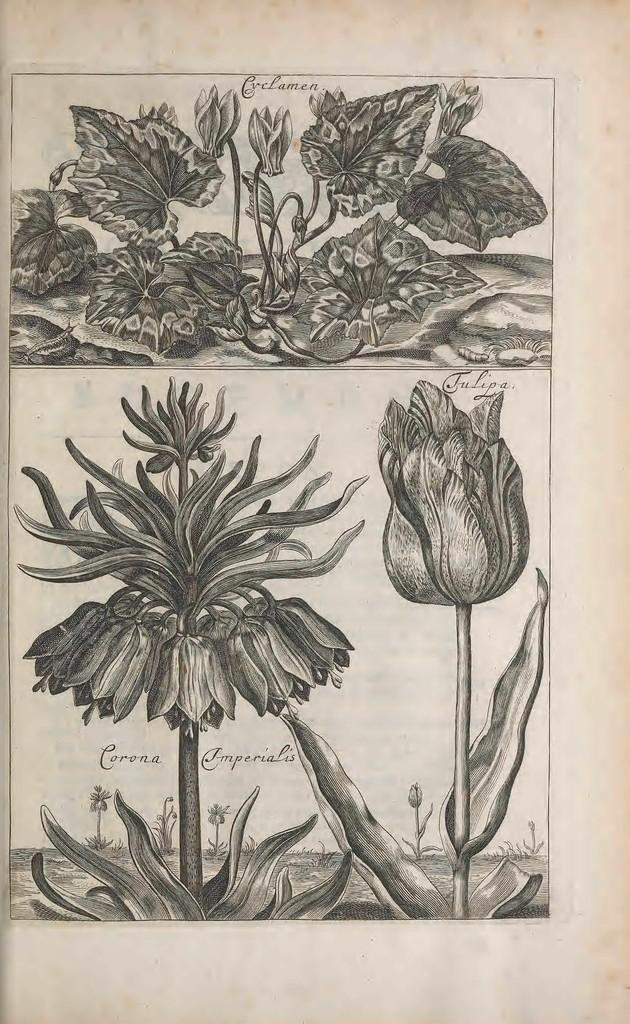What is depicted in the image? The image contains a sketch of flowers. What is the medium for the sketch? The sketch is on plants. What is the color of the paper? The paper is cream colored. Is there any text in the image? Yes, there is writing on the paper. What type of collar can be seen on the flowers in the image? There are no collars present on the flowers in the image, as it is a sketch of flowers on plants. How does the mist affect the appearance of the flowers in the image? There is no mist present in the image; it is a sketch of flowers on plants. 